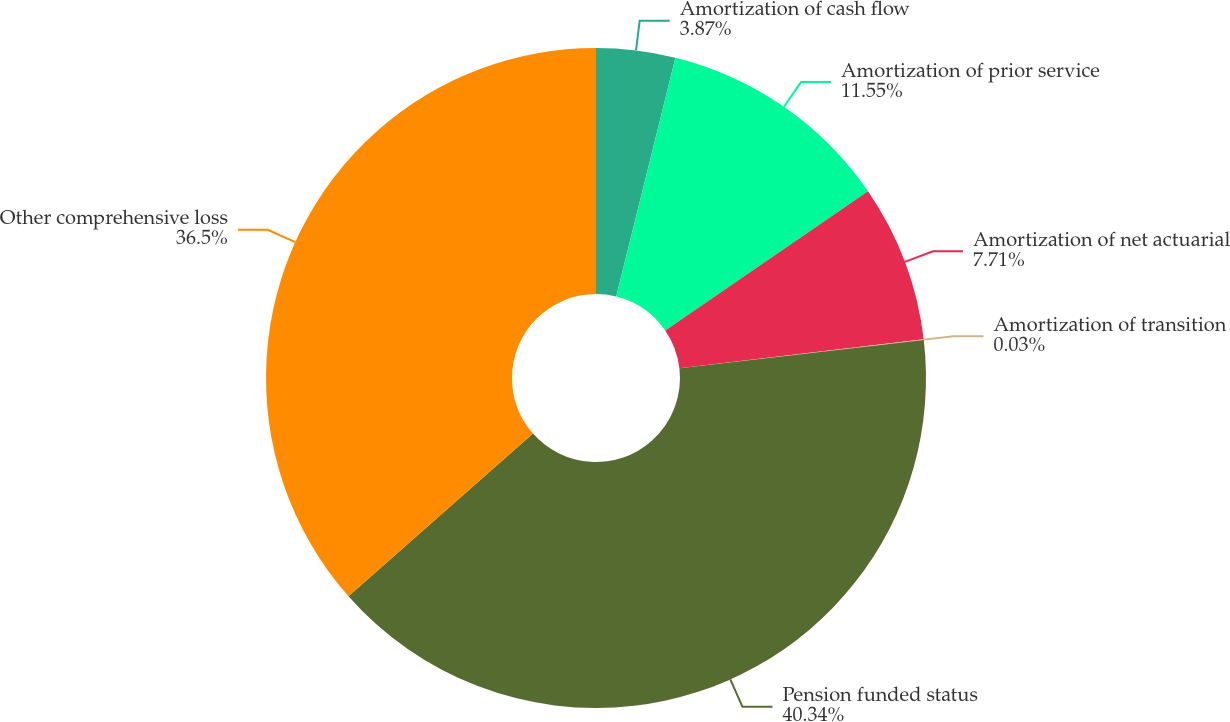Convert chart to OTSL. <chart><loc_0><loc_0><loc_500><loc_500><pie_chart><fcel>Amortization of cash flow<fcel>Amortization of prior service<fcel>Amortization of net actuarial<fcel>Amortization of transition<fcel>Pension funded status<fcel>Other comprehensive loss<nl><fcel>3.87%<fcel>11.55%<fcel>7.71%<fcel>0.03%<fcel>40.34%<fcel>36.5%<nl></chart> 